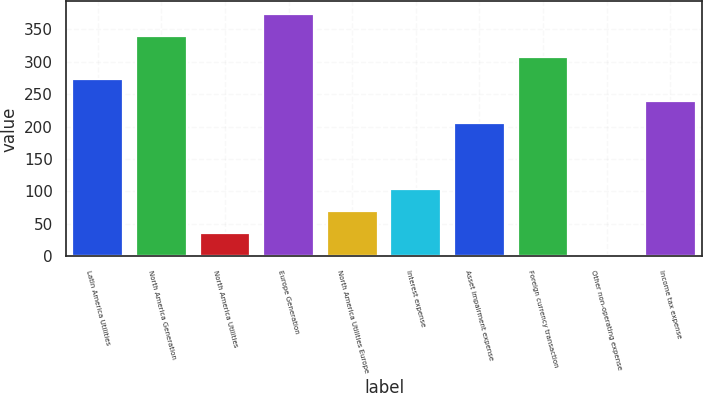Convert chart to OTSL. <chart><loc_0><loc_0><loc_500><loc_500><bar_chart><fcel>Latin America Utilities<fcel>North America Generation<fcel>North America Utilities<fcel>Europe Generation<fcel>North America Utilities Europe<fcel>Interest expense<fcel>Asset impairment expense<fcel>Foreign currency transaction<fcel>Other non-operating expense<fcel>Income tax expense<nl><fcel>272.6<fcel>340<fcel>36.7<fcel>373.7<fcel>70.4<fcel>104.1<fcel>205.2<fcel>306.3<fcel>3<fcel>238.9<nl></chart> 